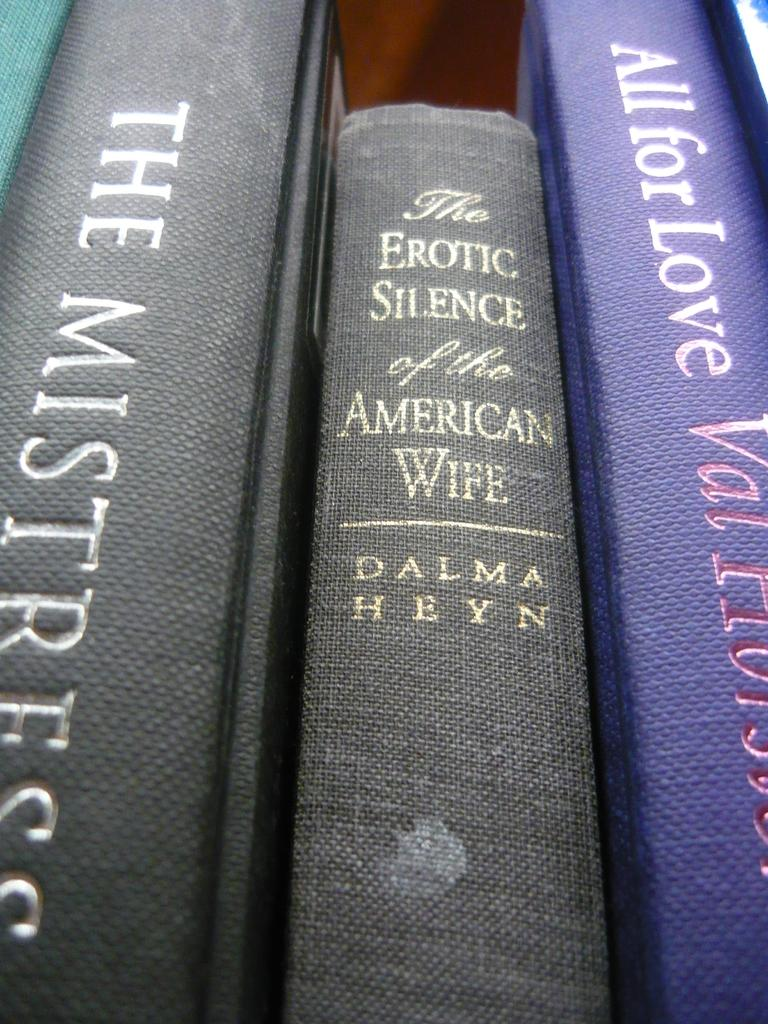Provide a one-sentence caption for the provided image. An up close view of a stack of books, the middle book is titled The Erotic Silence of the American Wife. 